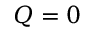Convert formula to latex. <formula><loc_0><loc_0><loc_500><loc_500>Q = 0</formula> 